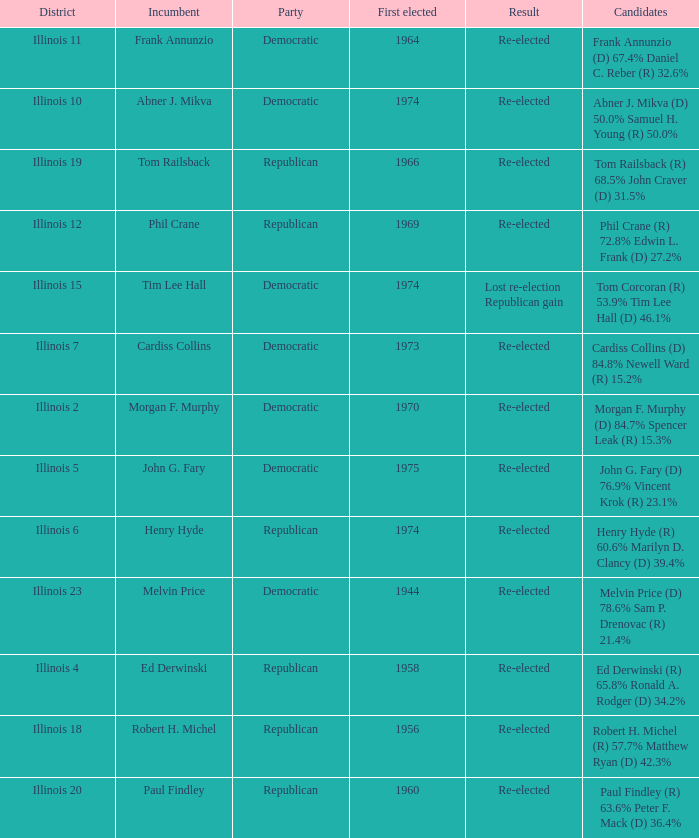Would you be able to parse every entry in this table? {'header': ['District', 'Incumbent', 'Party', 'First elected', 'Result', 'Candidates'], 'rows': [['Illinois 11', 'Frank Annunzio', 'Democratic', '1964', 'Re-elected', 'Frank Annunzio (D) 67.4% Daniel C. Reber (R) 32.6%'], ['Illinois 10', 'Abner J. Mikva', 'Democratic', '1974', 'Re-elected', 'Abner J. Mikva (D) 50.0% Samuel H. Young (R) 50.0%'], ['Illinois 19', 'Tom Railsback', 'Republican', '1966', 'Re-elected', 'Tom Railsback (R) 68.5% John Craver (D) 31.5%'], ['Illinois 12', 'Phil Crane', 'Republican', '1969', 'Re-elected', 'Phil Crane (R) 72.8% Edwin L. Frank (D) 27.2%'], ['Illinois 15', 'Tim Lee Hall', 'Democratic', '1974', 'Lost re-election Republican gain', 'Tom Corcoran (R) 53.9% Tim Lee Hall (D) 46.1%'], ['Illinois 7', 'Cardiss Collins', 'Democratic', '1973', 'Re-elected', 'Cardiss Collins (D) 84.8% Newell Ward (R) 15.2%'], ['Illinois 2', 'Morgan F. Murphy', 'Democratic', '1970', 'Re-elected', 'Morgan F. Murphy (D) 84.7% Spencer Leak (R) 15.3%'], ['Illinois 5', 'John G. Fary', 'Democratic', '1975', 'Re-elected', 'John G. Fary (D) 76.9% Vincent Krok (R) 23.1%'], ['Illinois 6', 'Henry Hyde', 'Republican', '1974', 'Re-elected', 'Henry Hyde (R) 60.6% Marilyn D. Clancy (D) 39.4%'], ['Illinois 23', 'Melvin Price', 'Democratic', '1944', 'Re-elected', 'Melvin Price (D) 78.6% Sam P. Drenovac (R) 21.4%'], ['Illinois 4', 'Ed Derwinski', 'Republican', '1958', 'Re-elected', 'Ed Derwinski (R) 65.8% Ronald A. Rodger (D) 34.2%'], ['Illinois 18', 'Robert H. Michel', 'Republican', '1956', 'Re-elected', 'Robert H. Michel (R) 57.7% Matthew Ryan (D) 42.3%'], ['Illinois 20', 'Paul Findley', 'Republican', '1960', 'Re-elected', 'Paul Findley (R) 63.6% Peter F. Mack (D) 36.4%']]} Name the party for tim lee hall Democratic. 